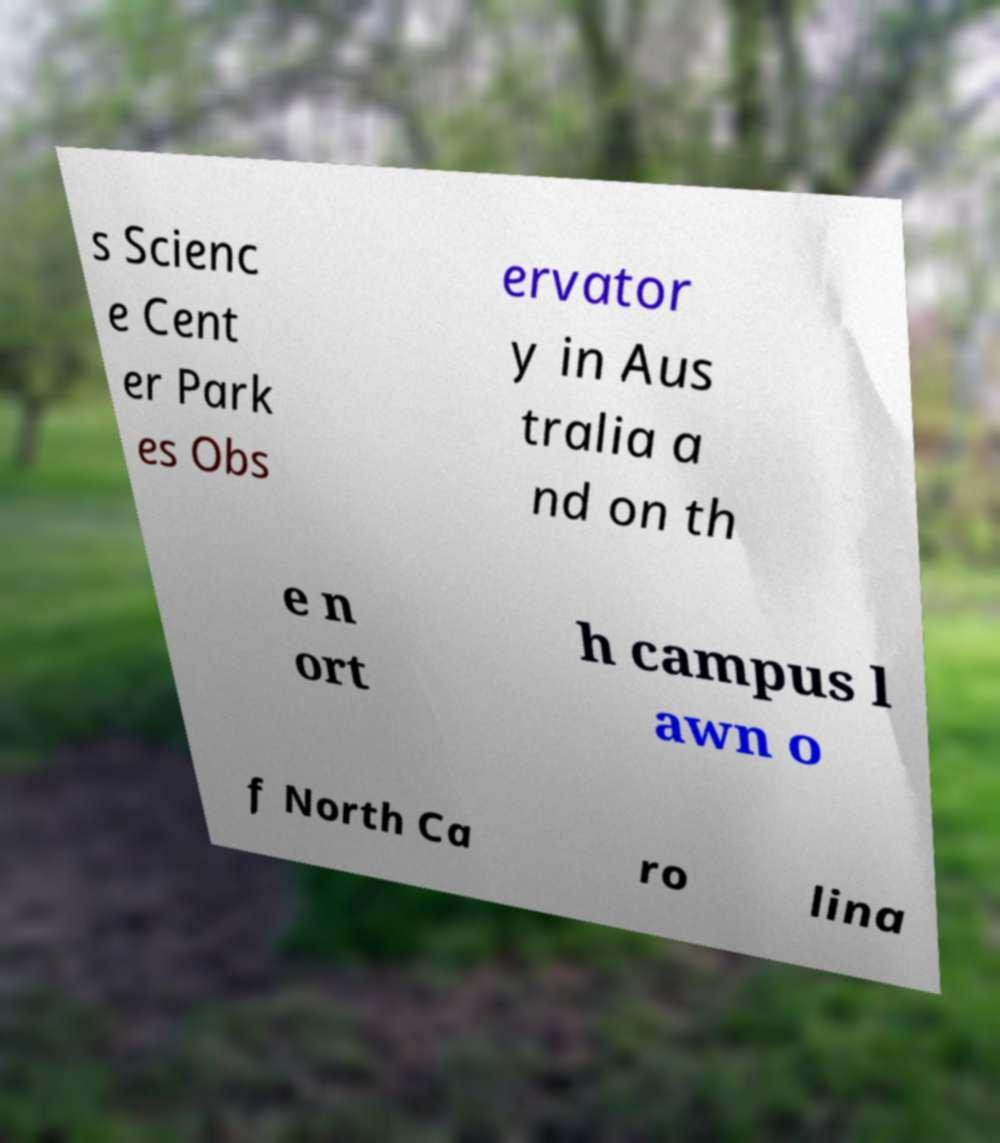Please identify and transcribe the text found in this image. s Scienc e Cent er Park es Obs ervator y in Aus tralia a nd on th e n ort h campus l awn o f North Ca ro lina 